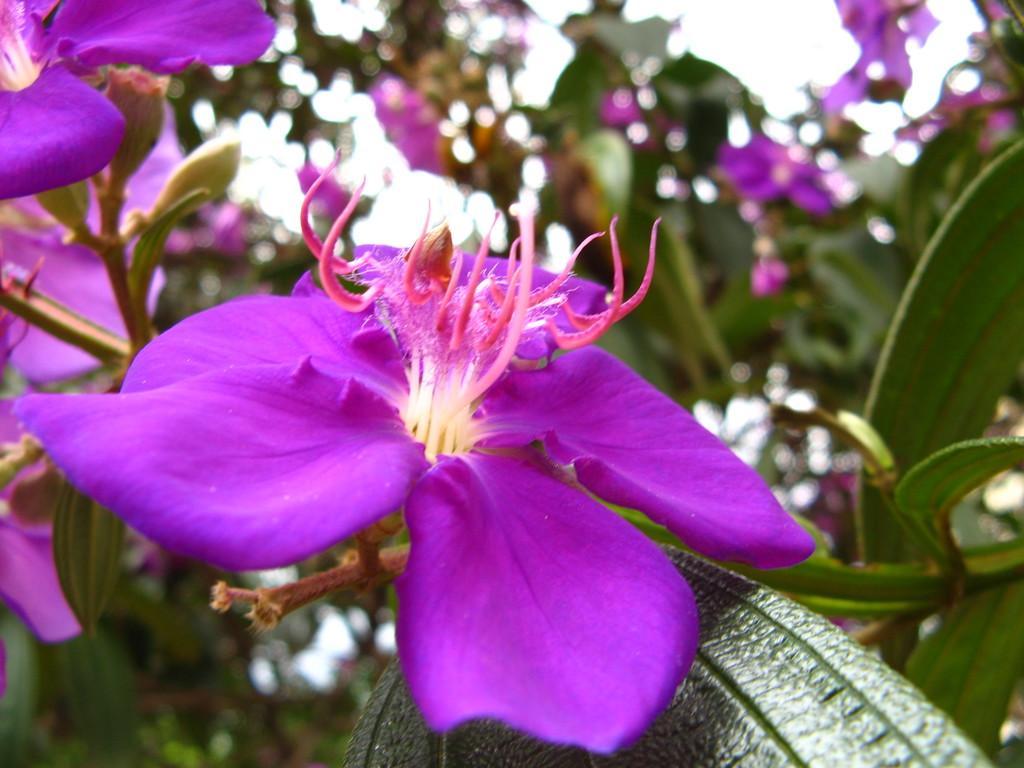In one or two sentences, can you explain what this image depicts? In this picture I can observe violet color flowers. The background is blurred. 